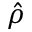Convert formula to latex. <formula><loc_0><loc_0><loc_500><loc_500>\hat { \rho }</formula> 